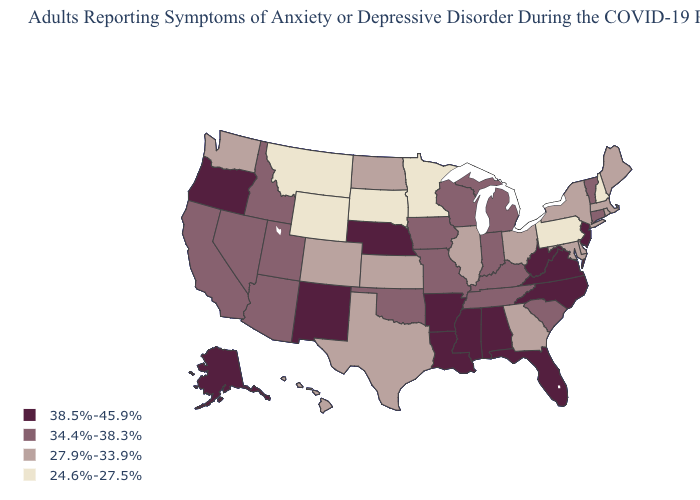What is the value of Utah?
Answer briefly. 34.4%-38.3%. What is the value of New Jersey?
Be succinct. 38.5%-45.9%. What is the value of South Carolina?
Give a very brief answer. 34.4%-38.3%. Which states have the lowest value in the USA?
Answer briefly. Minnesota, Montana, New Hampshire, Pennsylvania, South Dakota, Wyoming. What is the value of South Dakota?
Quick response, please. 24.6%-27.5%. Name the states that have a value in the range 27.9%-33.9%?
Quick response, please. Colorado, Delaware, Georgia, Hawaii, Illinois, Kansas, Maine, Maryland, Massachusetts, New York, North Dakota, Ohio, Rhode Island, Texas, Washington. Does Delaware have a lower value than New York?
Write a very short answer. No. What is the value of Alaska?
Be succinct. 38.5%-45.9%. What is the highest value in states that border Kansas?
Answer briefly. 38.5%-45.9%. What is the value of Ohio?
Write a very short answer. 27.9%-33.9%. What is the highest value in the USA?
Give a very brief answer. 38.5%-45.9%. Name the states that have a value in the range 27.9%-33.9%?
Concise answer only. Colorado, Delaware, Georgia, Hawaii, Illinois, Kansas, Maine, Maryland, Massachusetts, New York, North Dakota, Ohio, Rhode Island, Texas, Washington. Name the states that have a value in the range 34.4%-38.3%?
Quick response, please. Arizona, California, Connecticut, Idaho, Indiana, Iowa, Kentucky, Michigan, Missouri, Nevada, Oklahoma, South Carolina, Tennessee, Utah, Vermont, Wisconsin. Does New Hampshire have the lowest value in the USA?
Be succinct. Yes. Among the states that border South Dakota , which have the lowest value?
Concise answer only. Minnesota, Montana, Wyoming. 